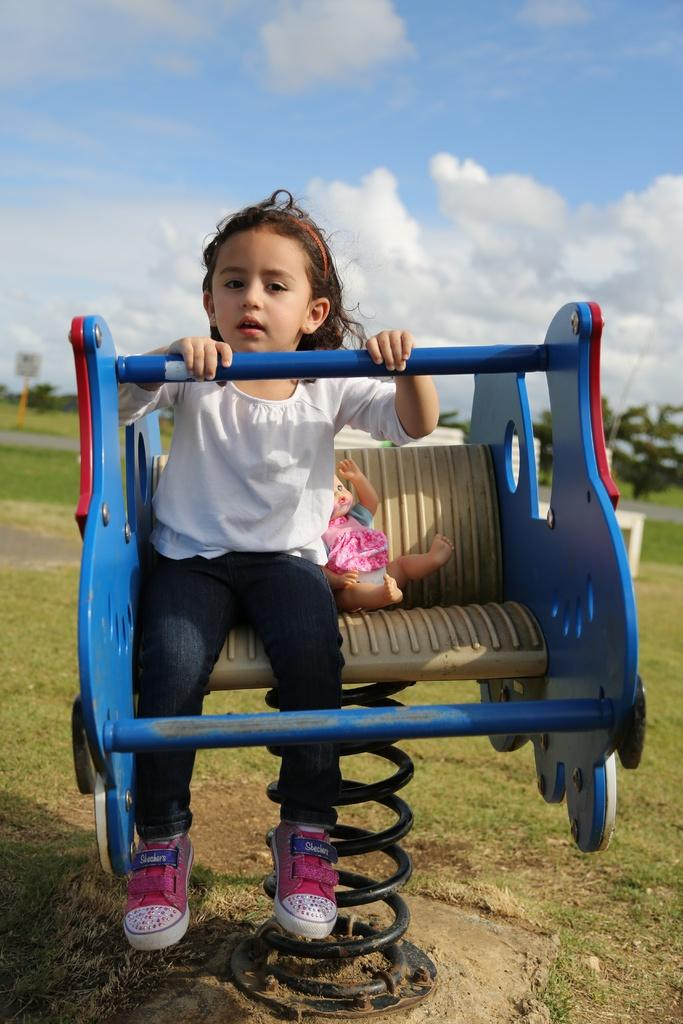What is the girl sitting on in the image? The girl is sitting on an object in the image. What color is the girl's top? The girl is wearing a white top. What type of pants is the girl wearing? The girl is wearing jeans. What type of footwear is the girl wearing? The girl is wearing shoes. What type of vegetation can be seen in the background of the image? There are trees and grass in the background of the image. What is visible in the sky in the background of the image? The sky is visible in the background of the image. What type of loaf is the girl holding in the image? There is no loaf present in the image. What achievement has the girl recently accomplished, as depicted in the image? The image does not show any achievements or accomplishments of the girl. 